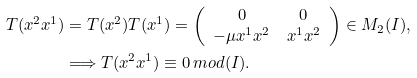Convert formula to latex. <formula><loc_0><loc_0><loc_500><loc_500>T ( x ^ { 2 } x ^ { 1 } ) & = T ( x ^ { 2 } ) T ( x ^ { 1 } ) = \left ( \begin{array} { c c } 0 & 0 \\ - \mu x ^ { 1 } x ^ { 2 } & x ^ { 1 } x ^ { 2 } \end{array} \right ) \in M _ { 2 } ( I ) , \\ & \Longrightarrow T ( x ^ { 2 } x ^ { 1 } ) \equiv 0 \, m o d ( I ) .</formula> 